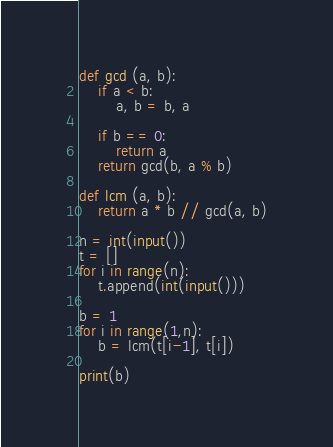<code> <loc_0><loc_0><loc_500><loc_500><_Python_>def gcd (a, b):
    if a < b:
        a, b = b, a
    
    if b == 0:
        return a
    return gcd(b, a % b)

def lcm (a, b):
    return a * b // gcd(a, b)

n = int(input())
t = []
for i in range(n):
    t.append(int(input()))

b = 1
for i in range(1,n):
    b = lcm(t[i-1], t[i])

print(b)</code> 